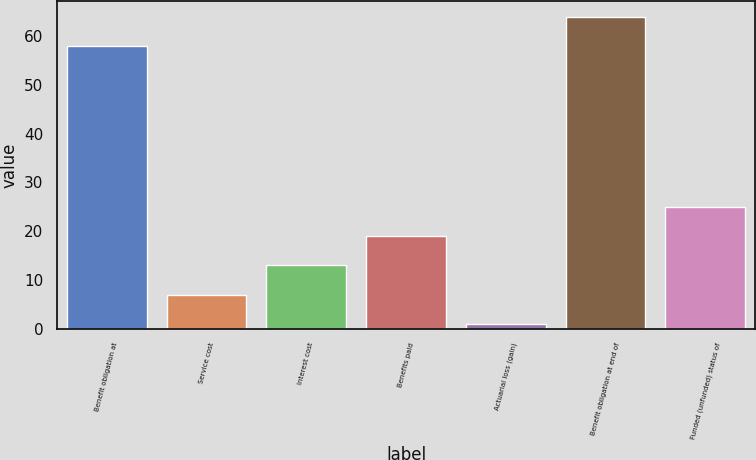Convert chart to OTSL. <chart><loc_0><loc_0><loc_500><loc_500><bar_chart><fcel>Benefit obligation at<fcel>Service cost<fcel>Interest cost<fcel>Benefits paid<fcel>Actuarial loss (gain)<fcel>Benefit obligation at end of<fcel>Funded (unfunded) status of<nl><fcel>58<fcel>7<fcel>13<fcel>19<fcel>1<fcel>64<fcel>25<nl></chart> 